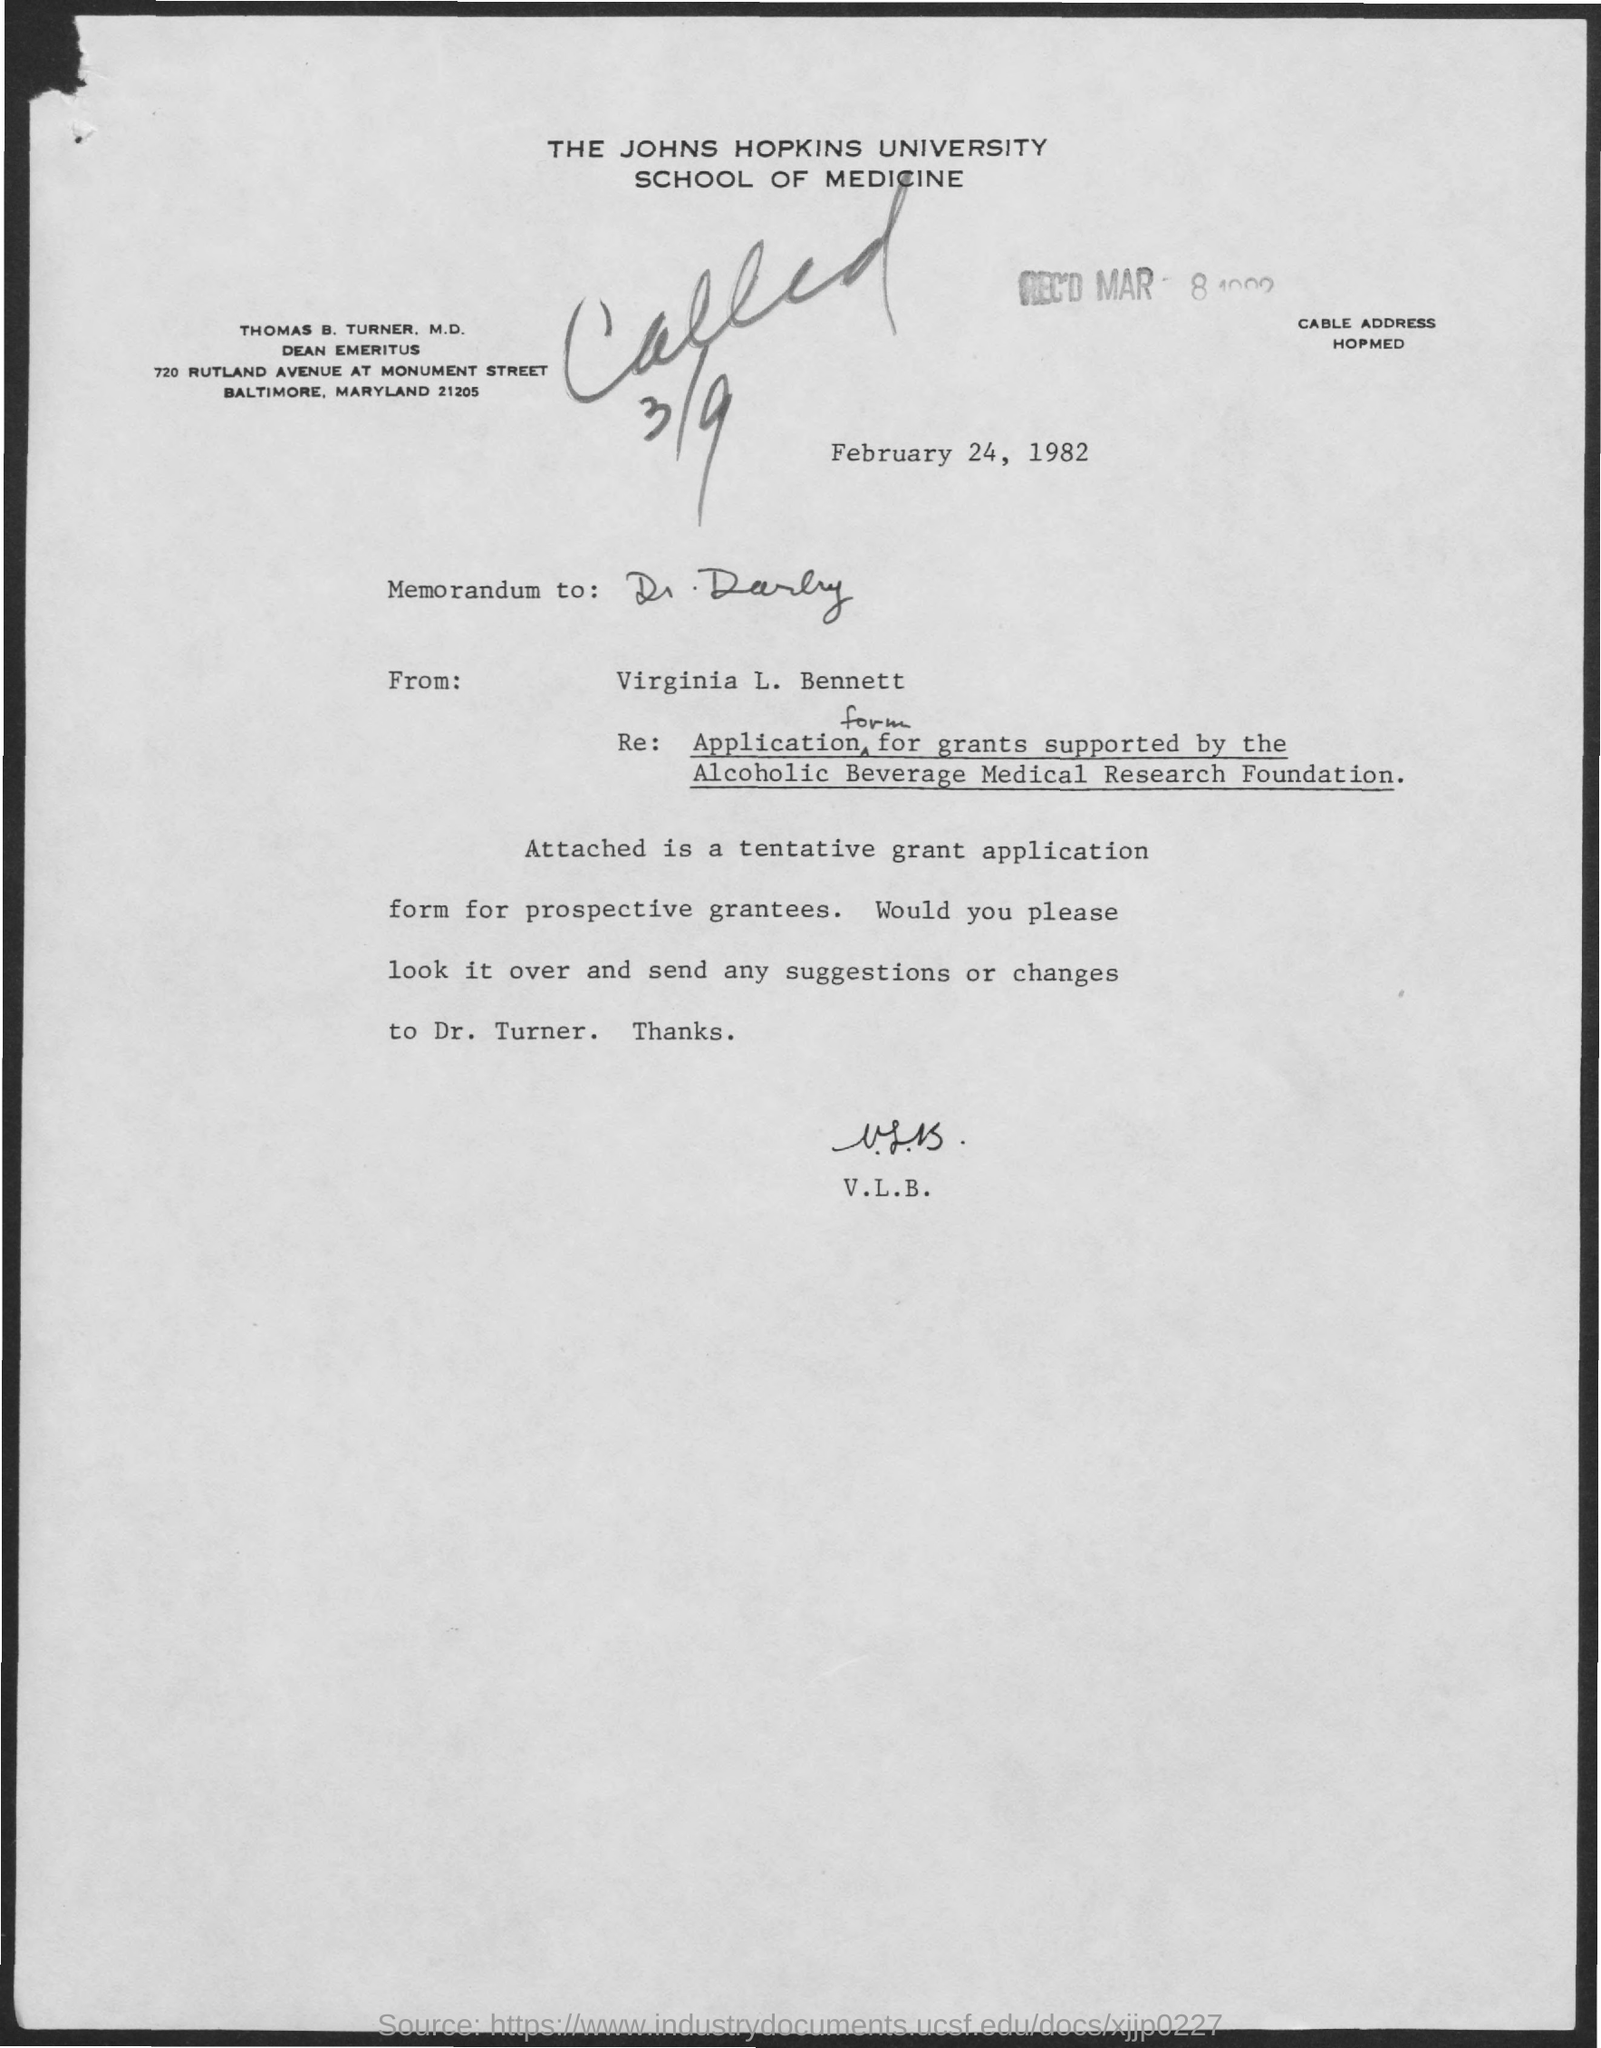What is written in the letter head ?
Provide a short and direct response. The johns hopkins university school of medicine. When is the memorandum dated on ?
Give a very brief answer. February 24, 1982. 